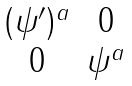<formula> <loc_0><loc_0><loc_500><loc_500>\begin{matrix} ( \psi ^ { \prime } ) ^ { a } & 0 \\ 0 & \psi ^ { a } \end{matrix}</formula> 